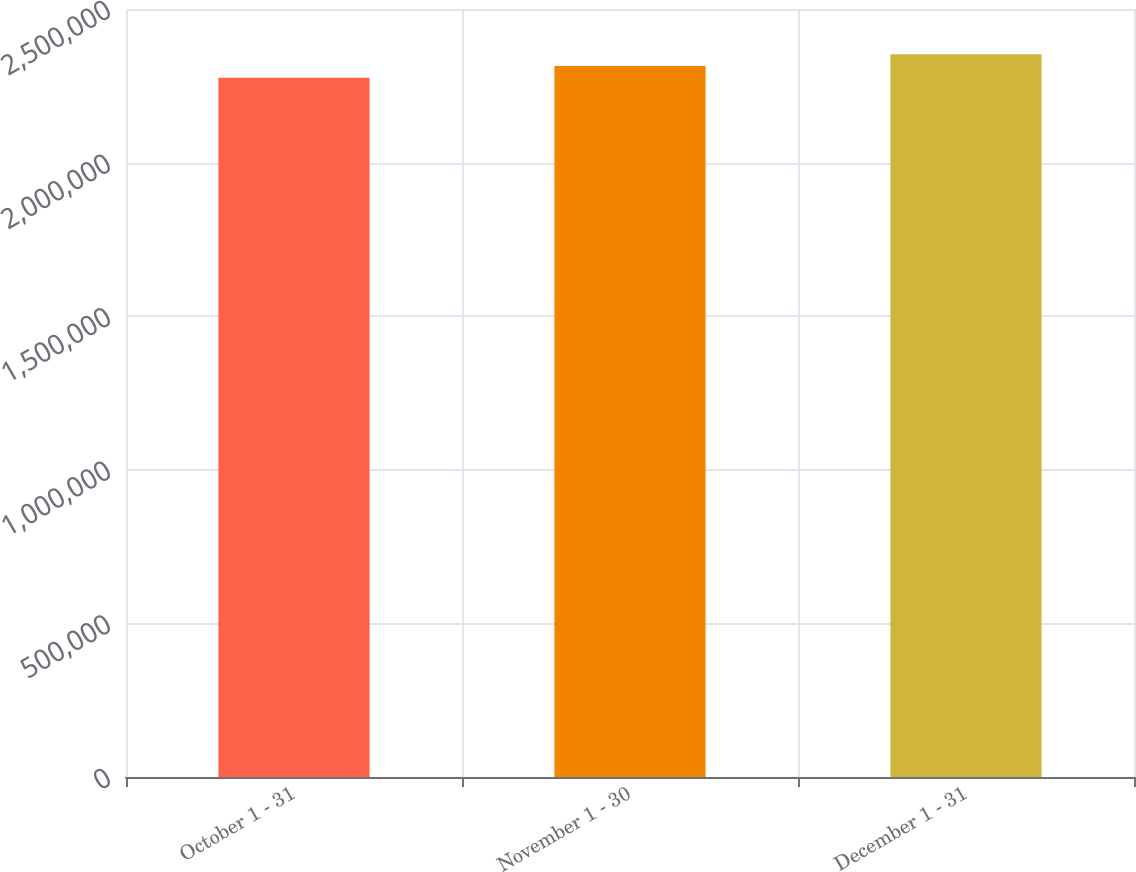<chart> <loc_0><loc_0><loc_500><loc_500><bar_chart><fcel>October 1 - 31<fcel>November 1 - 30<fcel>December 1 - 31<nl><fcel>2.27645e+06<fcel>2.31486e+06<fcel>2.35307e+06<nl></chart> 